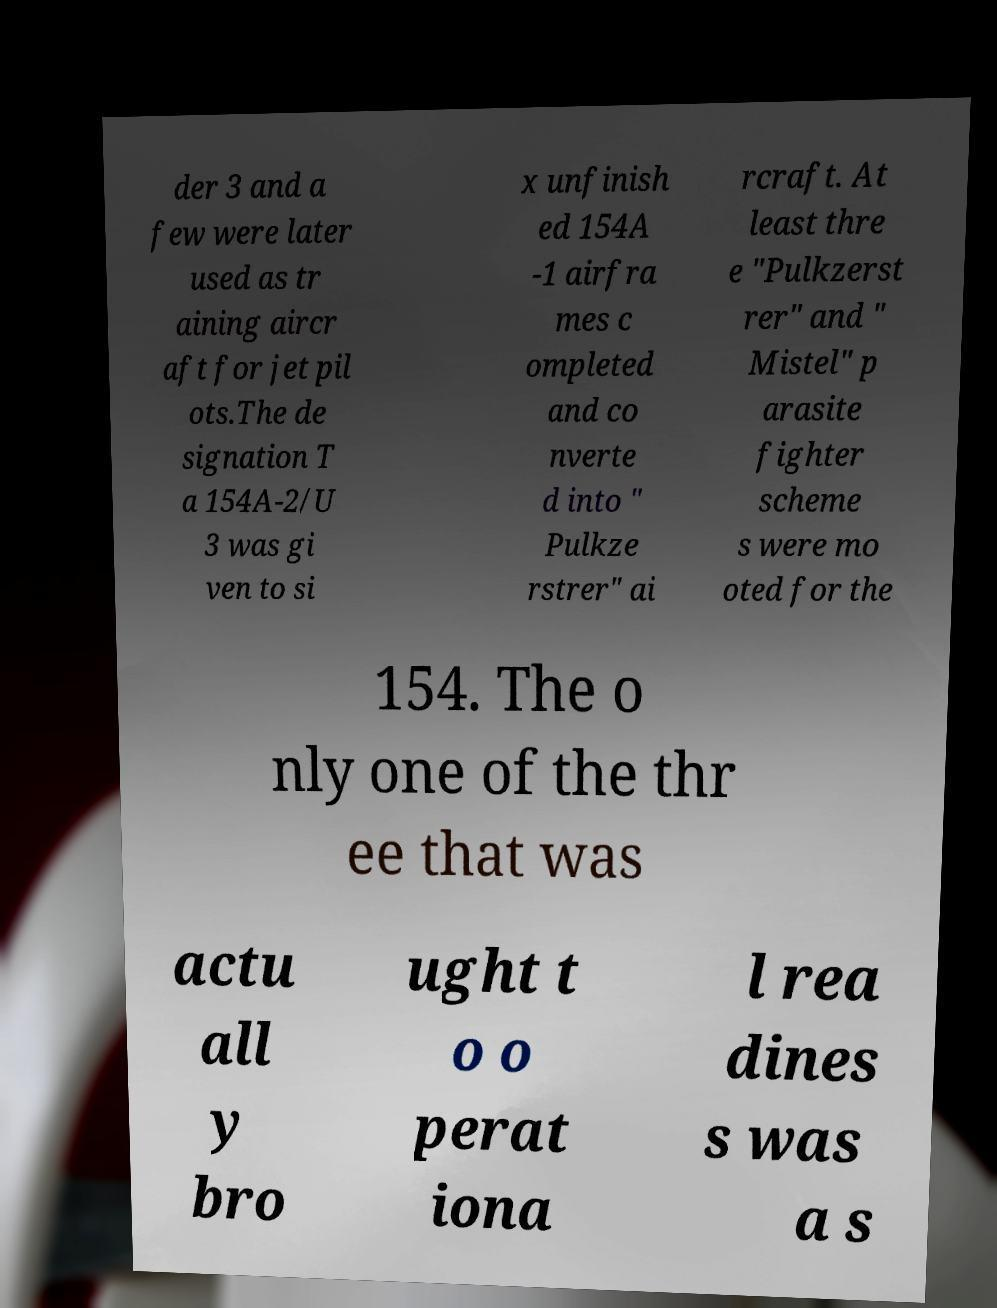Could you assist in decoding the text presented in this image and type it out clearly? der 3 and a few were later used as tr aining aircr aft for jet pil ots.The de signation T a 154A-2/U 3 was gi ven to si x unfinish ed 154A -1 airfra mes c ompleted and co nverte d into " Pulkze rstrer" ai rcraft. At least thre e "Pulkzerst rer" and " Mistel" p arasite fighter scheme s were mo oted for the 154. The o nly one of the thr ee that was actu all y bro ught t o o perat iona l rea dines s was a s 